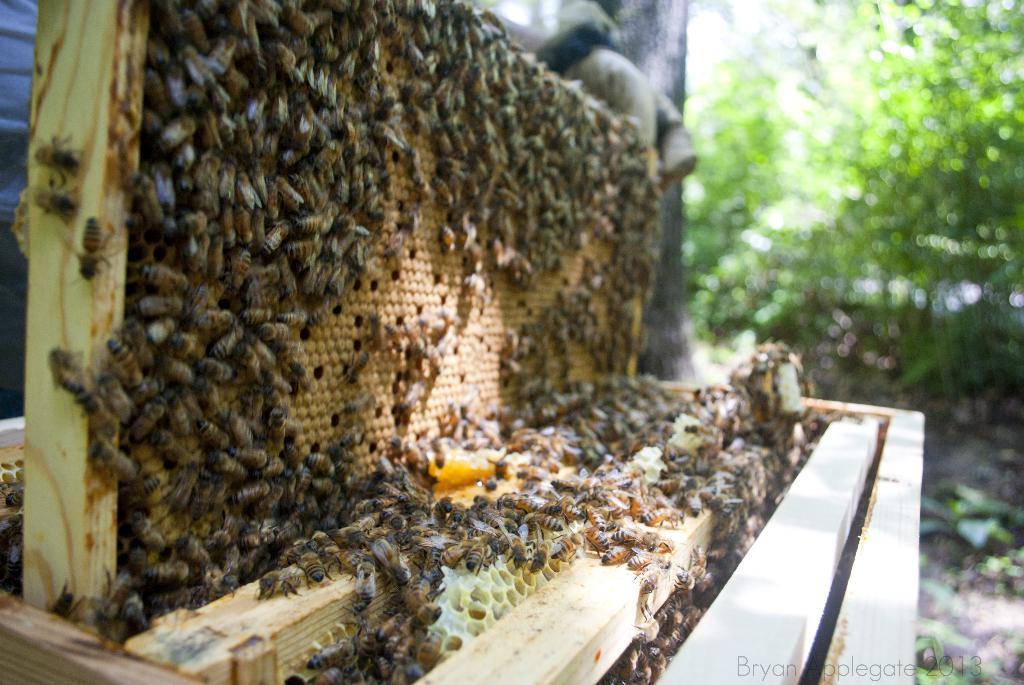Describe this image in one or two sentences. In this picture we can see honey bees here, on the left side there is a beehive, in the background there is a tree, we can see wood here. 